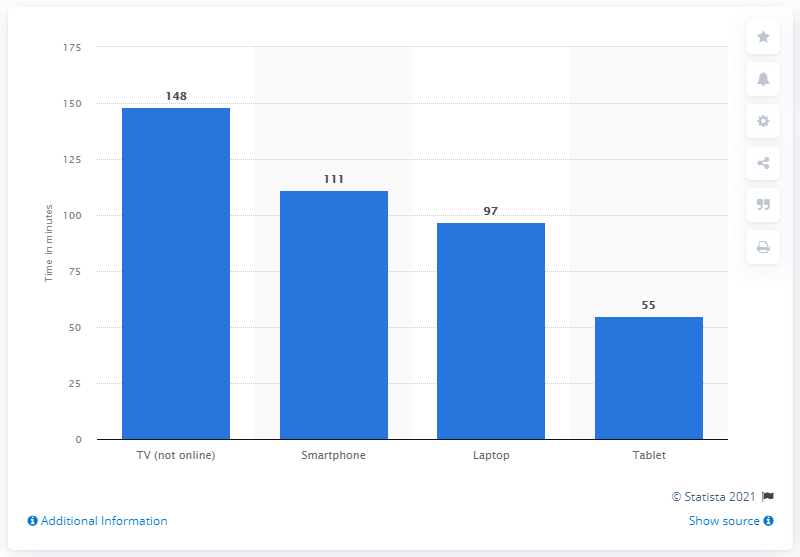Identify some key points in this picture. In the UK, multiscreen users spend an average of 148 minutes per day watching TV. 